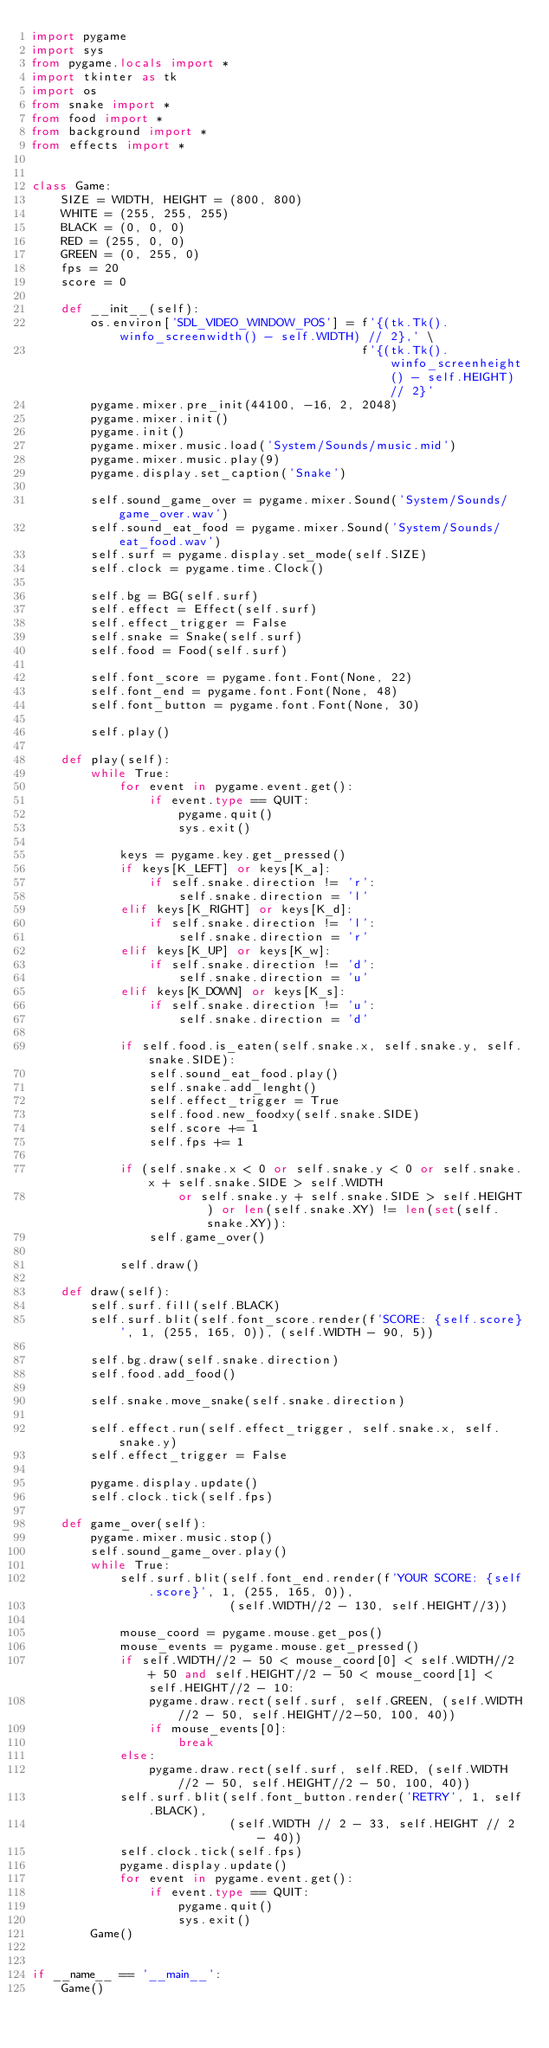Convert code to text. <code><loc_0><loc_0><loc_500><loc_500><_Python_>import pygame
import sys
from pygame.locals import *
import tkinter as tk
import os
from snake import *
from food import *
from background import *
from effects import *


class Game:
    SIZE = WIDTH, HEIGHT = (800, 800)
    WHITE = (255, 255, 255)
    BLACK = (0, 0, 0)
    RED = (255, 0, 0)
    GREEN = (0, 255, 0)
    fps = 20
    score = 0

    def __init__(self):
        os.environ['SDL_VIDEO_WINDOW_POS'] = f'{(tk.Tk().winfo_screenwidth() - self.WIDTH) // 2},' \
                                             f'{(tk.Tk().winfo_screenheight() - self.HEIGHT) // 2}'
        pygame.mixer.pre_init(44100, -16, 2, 2048)
        pygame.mixer.init()
        pygame.init()
        pygame.mixer.music.load('System/Sounds/music.mid')
        pygame.mixer.music.play(9)
        pygame.display.set_caption('Snake')

        self.sound_game_over = pygame.mixer.Sound('System/Sounds/game_over.wav')
        self.sound_eat_food = pygame.mixer.Sound('System/Sounds/eat_food.wav')
        self.surf = pygame.display.set_mode(self.SIZE)
        self.clock = pygame.time.Clock()

        self.bg = BG(self.surf)
        self.effect = Effect(self.surf)
        self.effect_trigger = False
        self.snake = Snake(self.surf)
        self.food = Food(self.surf)

        self.font_score = pygame.font.Font(None, 22)
        self.font_end = pygame.font.Font(None, 48)
        self.font_button = pygame.font.Font(None, 30)

        self.play()

    def play(self):
        while True:
            for event in pygame.event.get():
                if event.type == QUIT:
                    pygame.quit()
                    sys.exit()

            keys = pygame.key.get_pressed()
            if keys[K_LEFT] or keys[K_a]:
                if self.snake.direction != 'r':
                    self.snake.direction = 'l'
            elif keys[K_RIGHT] or keys[K_d]:
                if self.snake.direction != 'l':
                    self.snake.direction = 'r'
            elif keys[K_UP] or keys[K_w]:
                if self.snake.direction != 'd':
                    self.snake.direction = 'u'
            elif keys[K_DOWN] or keys[K_s]:
                if self.snake.direction != 'u':
                    self.snake.direction = 'd'

            if self.food.is_eaten(self.snake.x, self.snake.y, self.snake.SIDE):
                self.sound_eat_food.play()
                self.snake.add_lenght()
                self.effect_trigger = True
                self.food.new_foodxy(self.snake.SIDE)
                self.score += 1
                self.fps += 1

            if (self.snake.x < 0 or self.snake.y < 0 or self.snake.x + self.snake.SIDE > self.WIDTH
                    or self.snake.y + self.snake.SIDE > self.HEIGHT) or len(self.snake.XY) != len(set(self.snake.XY)):
                self.game_over()

            self.draw()

    def draw(self):
        self.surf.fill(self.BLACK)
        self.surf.blit(self.font_score.render(f'SCORE: {self.score}', 1, (255, 165, 0)), (self.WIDTH - 90, 5))

        self.bg.draw(self.snake.direction)
        self.food.add_food()

        self.snake.move_snake(self.snake.direction)

        self.effect.run(self.effect_trigger, self.snake.x, self.snake.y)
        self.effect_trigger = False

        pygame.display.update()
        self.clock.tick(self.fps)

    def game_over(self):
        pygame.mixer.music.stop()
        self.sound_game_over.play()
        while True:
            self.surf.blit(self.font_end.render(f'YOUR SCORE: {self.score}', 1, (255, 165, 0)),
                           (self.WIDTH//2 - 130, self.HEIGHT//3))

            mouse_coord = pygame.mouse.get_pos()
            mouse_events = pygame.mouse.get_pressed()
            if self.WIDTH//2 - 50 < mouse_coord[0] < self.WIDTH//2 + 50 and self.HEIGHT//2 - 50 < mouse_coord[1] < self.HEIGHT//2 - 10:
                pygame.draw.rect(self.surf, self.GREEN, (self.WIDTH//2 - 50, self.HEIGHT//2-50, 100, 40))
                if mouse_events[0]:
                    break
            else:
                pygame.draw.rect(self.surf, self.RED, (self.WIDTH//2 - 50, self.HEIGHT//2 - 50, 100, 40))
            self.surf.blit(self.font_button.render('RETRY', 1, self.BLACK),
                           (self.WIDTH // 2 - 33, self.HEIGHT // 2 - 40))
            self.clock.tick(self.fps)
            pygame.display.update()
            for event in pygame.event.get():
                if event.type == QUIT:
                    pygame.quit()
                    sys.exit()
        Game()


if __name__ == '__main__':
    Game()
</code> 